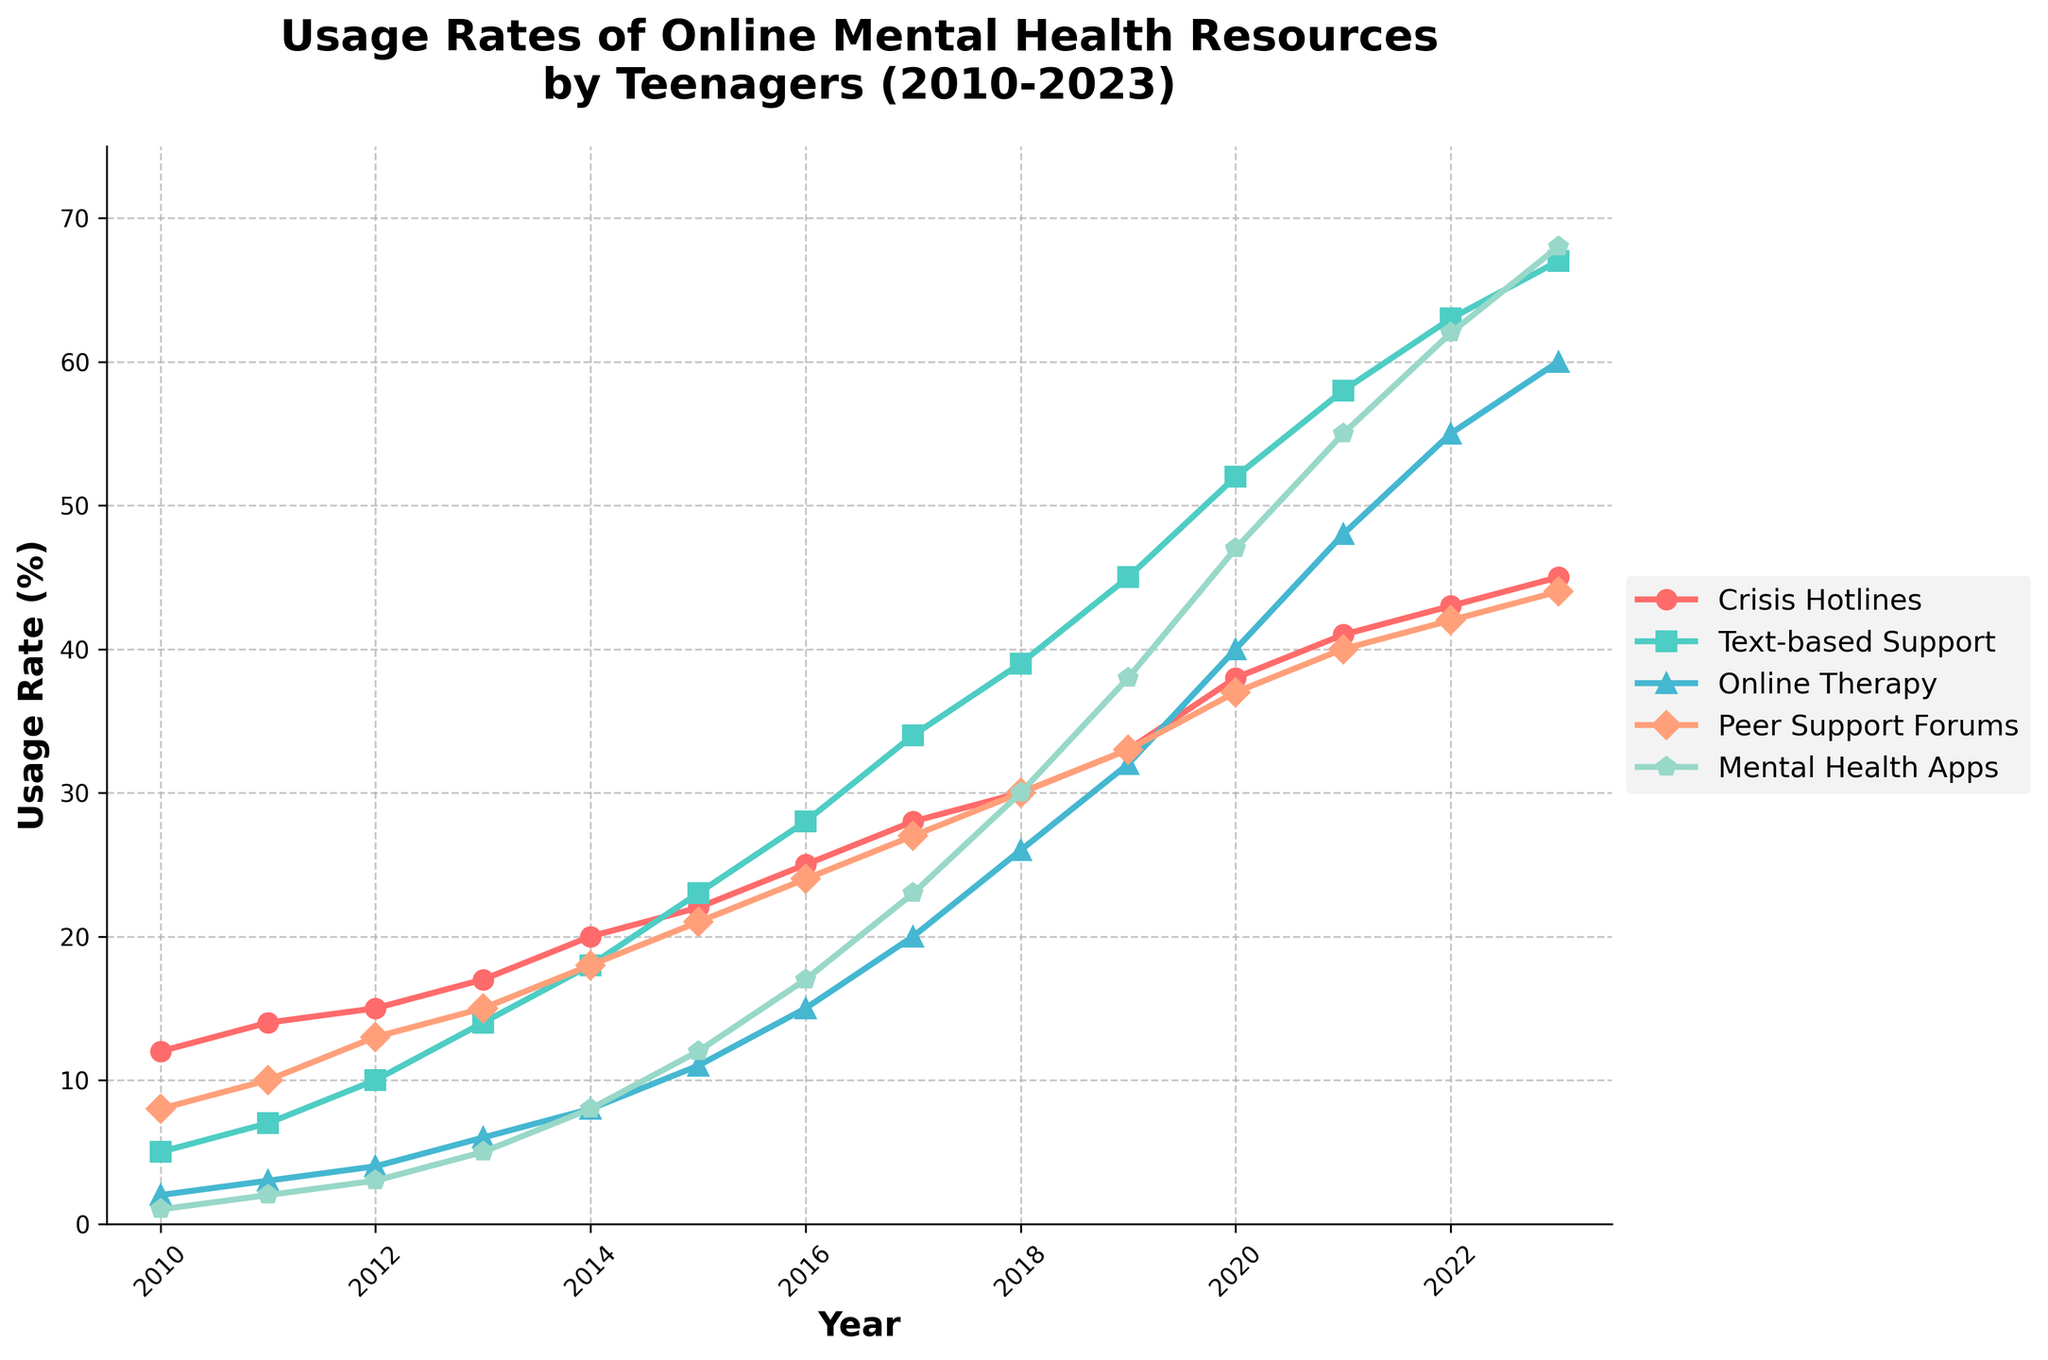Which service had the highest usage rate in 2010? The line chart shows various services with their respective usage rates for each year. For 2010, looking at the data points, Crisis Hotlines have the highest rate at 12%.
Answer: Crisis Hotlines Which service showed the greatest increase in usage from 2010 to 2023? First, check the usage rates for each service in 2010 and 2023, then subtract the 2010 value from the 2023 value for each service. Online Therapy increased from 2% to 60%, i.e., an increase of 58%. This is the greatest increase among all services.
Answer: Online Therapy How does the usage of Text-based Support in 2015 compare with that in 2023? Locate the data points for Text-based Support for the years 2015 and 2023. In 2015, the usage rate was 23%, and in 2023, it was 67%. Comparing these, 67% is significantly higher than 23%.
Answer: Higher in 2023 What’s the average usage rate of Peer Support Forums between 2010 and 2023? Sum up the usage rates for Peer Support Forums from 2010 to 2023 and then divide by the number of years (14). (8+10+13+15+18+21+24+27+30+33+37+40+42+44)/14 = 26.29%
Answer: 26.29% Which two services had the smallest difference in usage rates in 2020? Look at the data points for all services in 2020 and find the difference between each pair. The smallest difference is between Text-based Support (52%) and Online Therapy (40%), making a difference of 12%.
Answer: Text-based Support and Online Therapy What does the trend for Mental Health Apps look like from 2010 to 2023? Observe the line representing Mental Health Apps over the years. It starts at 1% in 2010 and steadily increases each year, reaching 68% in 2023. The trend shows a continuous upward path.
Answer: Continuous upward trend In which year did the usage rate of Crisis Hotlines surpass 30%? Identify the year when Crisis Hotlines first exceed 30% by looking at the data points. It happened in 2018 when the usage rate reached 30%.
Answer: 2018 Which service had the most stable growth from 2010 to 2023? Examine the slope and shape of each line. Crisis Hotlines show a consistent and steady growth over the period with no dramatic spikes or dips compared to the other services.
Answer: Crisis Hotlines Between 2015 and 2020, which service had the largest absolute increase in usage rate? Calculate the difference in usage rates between 2015 and 2020 for each service: Crisis Hotlines (38-22=16%), Text-based Support (52-23=29%), Online Therapy (40-11=29%), Peer Support Forums (37-21=16%), and Mental Health Apps (47-12=35%). Mental Health Apps had the largest increase.
Answer: Mental Health Apps 